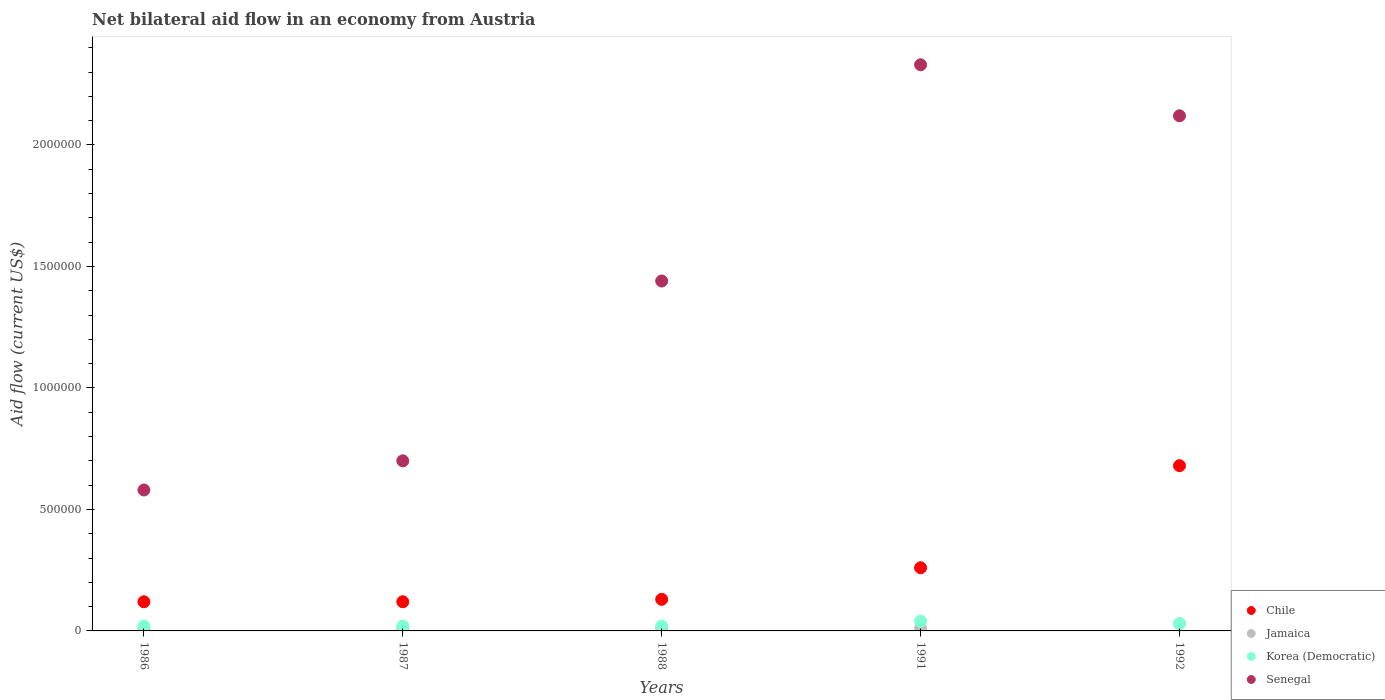Across all years, what is the maximum net bilateral aid flow in Senegal?
Provide a succinct answer. 2.33e+06. Across all years, what is the minimum net bilateral aid flow in Senegal?
Your response must be concise. 5.80e+05. In which year was the net bilateral aid flow in Senegal minimum?
Give a very brief answer. 1986. What is the difference between the net bilateral aid flow in Senegal in 1987 and that in 1988?
Your answer should be compact. -7.40e+05. What is the difference between the net bilateral aid flow in Korea (Democratic) in 1991 and the net bilateral aid flow in Jamaica in 1987?
Your response must be concise. 3.00e+04. What is the average net bilateral aid flow in Senegal per year?
Ensure brevity in your answer.  1.43e+06. In the year 1992, what is the difference between the net bilateral aid flow in Jamaica and net bilateral aid flow in Senegal?
Give a very brief answer. -2.09e+06. What is the ratio of the net bilateral aid flow in Korea (Democratic) in 1986 to that in 1991?
Give a very brief answer. 0.5. Is the difference between the net bilateral aid flow in Jamaica in 1986 and 1988 greater than the difference between the net bilateral aid flow in Senegal in 1986 and 1988?
Keep it short and to the point. Yes. What is the difference between the highest and the second highest net bilateral aid flow in Korea (Democratic)?
Provide a short and direct response. 10000. What is the difference between the highest and the lowest net bilateral aid flow in Chile?
Give a very brief answer. 5.60e+05. Is it the case that in every year, the sum of the net bilateral aid flow in Korea (Democratic) and net bilateral aid flow in Jamaica  is greater than the sum of net bilateral aid flow in Chile and net bilateral aid flow in Senegal?
Make the answer very short. No. Is it the case that in every year, the sum of the net bilateral aid flow in Korea (Democratic) and net bilateral aid flow in Jamaica  is greater than the net bilateral aid flow in Senegal?
Keep it short and to the point. No. Does the net bilateral aid flow in Korea (Democratic) monotonically increase over the years?
Your answer should be very brief. No. Is the net bilateral aid flow in Jamaica strictly greater than the net bilateral aid flow in Senegal over the years?
Provide a succinct answer. No. How many years are there in the graph?
Your response must be concise. 5. Are the values on the major ticks of Y-axis written in scientific E-notation?
Offer a very short reply. No. How many legend labels are there?
Offer a terse response. 4. What is the title of the graph?
Your response must be concise. Net bilateral aid flow in an economy from Austria. Does "New Zealand" appear as one of the legend labels in the graph?
Keep it short and to the point. No. What is the Aid flow (current US$) in Jamaica in 1986?
Your response must be concise. 10000. What is the Aid flow (current US$) of Korea (Democratic) in 1986?
Make the answer very short. 2.00e+04. What is the Aid flow (current US$) of Senegal in 1986?
Provide a short and direct response. 5.80e+05. What is the Aid flow (current US$) of Jamaica in 1987?
Keep it short and to the point. 10000. What is the Aid flow (current US$) in Senegal in 1987?
Your answer should be very brief. 7.00e+05. What is the Aid flow (current US$) of Korea (Democratic) in 1988?
Provide a succinct answer. 2.00e+04. What is the Aid flow (current US$) in Senegal in 1988?
Your answer should be compact. 1.44e+06. What is the Aid flow (current US$) of Chile in 1991?
Provide a short and direct response. 2.60e+05. What is the Aid flow (current US$) in Jamaica in 1991?
Keep it short and to the point. 10000. What is the Aid flow (current US$) of Korea (Democratic) in 1991?
Provide a short and direct response. 4.00e+04. What is the Aid flow (current US$) of Senegal in 1991?
Make the answer very short. 2.33e+06. What is the Aid flow (current US$) of Chile in 1992?
Offer a very short reply. 6.80e+05. What is the Aid flow (current US$) in Jamaica in 1992?
Your answer should be compact. 3.00e+04. What is the Aid flow (current US$) in Senegal in 1992?
Offer a terse response. 2.12e+06. Across all years, what is the maximum Aid flow (current US$) in Chile?
Provide a succinct answer. 6.80e+05. Across all years, what is the maximum Aid flow (current US$) of Jamaica?
Your answer should be compact. 3.00e+04. Across all years, what is the maximum Aid flow (current US$) in Korea (Democratic)?
Your answer should be very brief. 4.00e+04. Across all years, what is the maximum Aid flow (current US$) in Senegal?
Offer a very short reply. 2.33e+06. Across all years, what is the minimum Aid flow (current US$) of Jamaica?
Offer a terse response. 10000. Across all years, what is the minimum Aid flow (current US$) of Senegal?
Your answer should be compact. 5.80e+05. What is the total Aid flow (current US$) of Chile in the graph?
Your response must be concise. 1.31e+06. What is the total Aid flow (current US$) in Jamaica in the graph?
Keep it short and to the point. 7.00e+04. What is the total Aid flow (current US$) in Senegal in the graph?
Your answer should be compact. 7.17e+06. What is the difference between the Aid flow (current US$) in Chile in 1986 and that in 1987?
Keep it short and to the point. 0. What is the difference between the Aid flow (current US$) in Jamaica in 1986 and that in 1987?
Offer a terse response. 0. What is the difference between the Aid flow (current US$) of Korea (Democratic) in 1986 and that in 1987?
Your response must be concise. 0. What is the difference between the Aid flow (current US$) in Senegal in 1986 and that in 1987?
Your answer should be very brief. -1.20e+05. What is the difference between the Aid flow (current US$) of Jamaica in 1986 and that in 1988?
Your answer should be compact. 0. What is the difference between the Aid flow (current US$) of Korea (Democratic) in 1986 and that in 1988?
Keep it short and to the point. 0. What is the difference between the Aid flow (current US$) of Senegal in 1986 and that in 1988?
Give a very brief answer. -8.60e+05. What is the difference between the Aid flow (current US$) of Chile in 1986 and that in 1991?
Offer a terse response. -1.40e+05. What is the difference between the Aid flow (current US$) in Jamaica in 1986 and that in 1991?
Offer a very short reply. 0. What is the difference between the Aid flow (current US$) in Korea (Democratic) in 1986 and that in 1991?
Your answer should be very brief. -2.00e+04. What is the difference between the Aid flow (current US$) in Senegal in 1986 and that in 1991?
Ensure brevity in your answer.  -1.75e+06. What is the difference between the Aid flow (current US$) of Chile in 1986 and that in 1992?
Your response must be concise. -5.60e+05. What is the difference between the Aid flow (current US$) in Senegal in 1986 and that in 1992?
Keep it short and to the point. -1.54e+06. What is the difference between the Aid flow (current US$) of Chile in 1987 and that in 1988?
Offer a very short reply. -10000. What is the difference between the Aid flow (current US$) of Jamaica in 1987 and that in 1988?
Offer a very short reply. 0. What is the difference between the Aid flow (current US$) in Korea (Democratic) in 1987 and that in 1988?
Make the answer very short. 0. What is the difference between the Aid flow (current US$) of Senegal in 1987 and that in 1988?
Provide a short and direct response. -7.40e+05. What is the difference between the Aid flow (current US$) in Chile in 1987 and that in 1991?
Provide a short and direct response. -1.40e+05. What is the difference between the Aid flow (current US$) of Korea (Democratic) in 1987 and that in 1991?
Make the answer very short. -2.00e+04. What is the difference between the Aid flow (current US$) in Senegal in 1987 and that in 1991?
Provide a succinct answer. -1.63e+06. What is the difference between the Aid flow (current US$) of Chile in 1987 and that in 1992?
Give a very brief answer. -5.60e+05. What is the difference between the Aid flow (current US$) in Senegal in 1987 and that in 1992?
Make the answer very short. -1.42e+06. What is the difference between the Aid flow (current US$) in Chile in 1988 and that in 1991?
Make the answer very short. -1.30e+05. What is the difference between the Aid flow (current US$) in Jamaica in 1988 and that in 1991?
Your answer should be compact. 0. What is the difference between the Aid flow (current US$) in Senegal in 1988 and that in 1991?
Ensure brevity in your answer.  -8.90e+05. What is the difference between the Aid flow (current US$) of Chile in 1988 and that in 1992?
Offer a very short reply. -5.50e+05. What is the difference between the Aid flow (current US$) of Jamaica in 1988 and that in 1992?
Give a very brief answer. -2.00e+04. What is the difference between the Aid flow (current US$) in Korea (Democratic) in 1988 and that in 1992?
Your response must be concise. -10000. What is the difference between the Aid flow (current US$) in Senegal in 1988 and that in 1992?
Offer a terse response. -6.80e+05. What is the difference between the Aid flow (current US$) of Chile in 1991 and that in 1992?
Your answer should be compact. -4.20e+05. What is the difference between the Aid flow (current US$) in Korea (Democratic) in 1991 and that in 1992?
Give a very brief answer. 10000. What is the difference between the Aid flow (current US$) of Chile in 1986 and the Aid flow (current US$) of Jamaica in 1987?
Your answer should be compact. 1.10e+05. What is the difference between the Aid flow (current US$) of Chile in 1986 and the Aid flow (current US$) of Korea (Democratic) in 1987?
Make the answer very short. 1.00e+05. What is the difference between the Aid flow (current US$) in Chile in 1986 and the Aid flow (current US$) in Senegal in 1987?
Ensure brevity in your answer.  -5.80e+05. What is the difference between the Aid flow (current US$) of Jamaica in 1986 and the Aid flow (current US$) of Senegal in 1987?
Provide a short and direct response. -6.90e+05. What is the difference between the Aid flow (current US$) of Korea (Democratic) in 1986 and the Aid flow (current US$) of Senegal in 1987?
Keep it short and to the point. -6.80e+05. What is the difference between the Aid flow (current US$) of Chile in 1986 and the Aid flow (current US$) of Jamaica in 1988?
Make the answer very short. 1.10e+05. What is the difference between the Aid flow (current US$) of Chile in 1986 and the Aid flow (current US$) of Senegal in 1988?
Your answer should be compact. -1.32e+06. What is the difference between the Aid flow (current US$) of Jamaica in 1986 and the Aid flow (current US$) of Korea (Democratic) in 1988?
Your response must be concise. -10000. What is the difference between the Aid flow (current US$) of Jamaica in 1986 and the Aid flow (current US$) of Senegal in 1988?
Offer a terse response. -1.43e+06. What is the difference between the Aid flow (current US$) in Korea (Democratic) in 1986 and the Aid flow (current US$) in Senegal in 1988?
Give a very brief answer. -1.42e+06. What is the difference between the Aid flow (current US$) of Chile in 1986 and the Aid flow (current US$) of Senegal in 1991?
Provide a succinct answer. -2.21e+06. What is the difference between the Aid flow (current US$) in Jamaica in 1986 and the Aid flow (current US$) in Korea (Democratic) in 1991?
Provide a succinct answer. -3.00e+04. What is the difference between the Aid flow (current US$) of Jamaica in 1986 and the Aid flow (current US$) of Senegal in 1991?
Your answer should be compact. -2.32e+06. What is the difference between the Aid flow (current US$) in Korea (Democratic) in 1986 and the Aid flow (current US$) in Senegal in 1991?
Provide a short and direct response. -2.31e+06. What is the difference between the Aid flow (current US$) of Chile in 1986 and the Aid flow (current US$) of Jamaica in 1992?
Keep it short and to the point. 9.00e+04. What is the difference between the Aid flow (current US$) of Jamaica in 1986 and the Aid flow (current US$) of Senegal in 1992?
Give a very brief answer. -2.11e+06. What is the difference between the Aid flow (current US$) of Korea (Democratic) in 1986 and the Aid flow (current US$) of Senegal in 1992?
Offer a terse response. -2.10e+06. What is the difference between the Aid flow (current US$) of Chile in 1987 and the Aid flow (current US$) of Korea (Democratic) in 1988?
Keep it short and to the point. 1.00e+05. What is the difference between the Aid flow (current US$) of Chile in 1987 and the Aid flow (current US$) of Senegal in 1988?
Give a very brief answer. -1.32e+06. What is the difference between the Aid flow (current US$) of Jamaica in 1987 and the Aid flow (current US$) of Korea (Democratic) in 1988?
Make the answer very short. -10000. What is the difference between the Aid flow (current US$) of Jamaica in 1987 and the Aid flow (current US$) of Senegal in 1988?
Your response must be concise. -1.43e+06. What is the difference between the Aid flow (current US$) in Korea (Democratic) in 1987 and the Aid flow (current US$) in Senegal in 1988?
Provide a short and direct response. -1.42e+06. What is the difference between the Aid flow (current US$) in Chile in 1987 and the Aid flow (current US$) in Senegal in 1991?
Offer a terse response. -2.21e+06. What is the difference between the Aid flow (current US$) in Jamaica in 1987 and the Aid flow (current US$) in Korea (Democratic) in 1991?
Offer a terse response. -3.00e+04. What is the difference between the Aid flow (current US$) in Jamaica in 1987 and the Aid flow (current US$) in Senegal in 1991?
Ensure brevity in your answer.  -2.32e+06. What is the difference between the Aid flow (current US$) of Korea (Democratic) in 1987 and the Aid flow (current US$) of Senegal in 1991?
Your answer should be very brief. -2.31e+06. What is the difference between the Aid flow (current US$) in Chile in 1987 and the Aid flow (current US$) in Jamaica in 1992?
Provide a short and direct response. 9.00e+04. What is the difference between the Aid flow (current US$) in Chile in 1987 and the Aid flow (current US$) in Senegal in 1992?
Your answer should be very brief. -2.00e+06. What is the difference between the Aid flow (current US$) of Jamaica in 1987 and the Aid flow (current US$) of Senegal in 1992?
Give a very brief answer. -2.11e+06. What is the difference between the Aid flow (current US$) in Korea (Democratic) in 1987 and the Aid flow (current US$) in Senegal in 1992?
Keep it short and to the point. -2.10e+06. What is the difference between the Aid flow (current US$) of Chile in 1988 and the Aid flow (current US$) of Korea (Democratic) in 1991?
Provide a short and direct response. 9.00e+04. What is the difference between the Aid flow (current US$) in Chile in 1988 and the Aid flow (current US$) in Senegal in 1991?
Give a very brief answer. -2.20e+06. What is the difference between the Aid flow (current US$) of Jamaica in 1988 and the Aid flow (current US$) of Korea (Democratic) in 1991?
Your answer should be very brief. -3.00e+04. What is the difference between the Aid flow (current US$) in Jamaica in 1988 and the Aid flow (current US$) in Senegal in 1991?
Make the answer very short. -2.32e+06. What is the difference between the Aid flow (current US$) of Korea (Democratic) in 1988 and the Aid flow (current US$) of Senegal in 1991?
Keep it short and to the point. -2.31e+06. What is the difference between the Aid flow (current US$) of Chile in 1988 and the Aid flow (current US$) of Korea (Democratic) in 1992?
Offer a very short reply. 1.00e+05. What is the difference between the Aid flow (current US$) in Chile in 1988 and the Aid flow (current US$) in Senegal in 1992?
Give a very brief answer. -1.99e+06. What is the difference between the Aid flow (current US$) in Jamaica in 1988 and the Aid flow (current US$) in Senegal in 1992?
Provide a succinct answer. -2.11e+06. What is the difference between the Aid flow (current US$) of Korea (Democratic) in 1988 and the Aid flow (current US$) of Senegal in 1992?
Offer a terse response. -2.10e+06. What is the difference between the Aid flow (current US$) of Chile in 1991 and the Aid flow (current US$) of Senegal in 1992?
Offer a terse response. -1.86e+06. What is the difference between the Aid flow (current US$) in Jamaica in 1991 and the Aid flow (current US$) in Korea (Democratic) in 1992?
Offer a very short reply. -2.00e+04. What is the difference between the Aid flow (current US$) of Jamaica in 1991 and the Aid flow (current US$) of Senegal in 1992?
Keep it short and to the point. -2.11e+06. What is the difference between the Aid flow (current US$) of Korea (Democratic) in 1991 and the Aid flow (current US$) of Senegal in 1992?
Give a very brief answer. -2.08e+06. What is the average Aid flow (current US$) in Chile per year?
Offer a very short reply. 2.62e+05. What is the average Aid flow (current US$) of Jamaica per year?
Provide a short and direct response. 1.40e+04. What is the average Aid flow (current US$) of Korea (Democratic) per year?
Provide a short and direct response. 2.60e+04. What is the average Aid flow (current US$) in Senegal per year?
Offer a very short reply. 1.43e+06. In the year 1986, what is the difference between the Aid flow (current US$) of Chile and Aid flow (current US$) of Korea (Democratic)?
Give a very brief answer. 1.00e+05. In the year 1986, what is the difference between the Aid flow (current US$) of Chile and Aid flow (current US$) of Senegal?
Ensure brevity in your answer.  -4.60e+05. In the year 1986, what is the difference between the Aid flow (current US$) in Jamaica and Aid flow (current US$) in Korea (Democratic)?
Provide a short and direct response. -10000. In the year 1986, what is the difference between the Aid flow (current US$) in Jamaica and Aid flow (current US$) in Senegal?
Offer a very short reply. -5.70e+05. In the year 1986, what is the difference between the Aid flow (current US$) in Korea (Democratic) and Aid flow (current US$) in Senegal?
Make the answer very short. -5.60e+05. In the year 1987, what is the difference between the Aid flow (current US$) in Chile and Aid flow (current US$) in Senegal?
Ensure brevity in your answer.  -5.80e+05. In the year 1987, what is the difference between the Aid flow (current US$) in Jamaica and Aid flow (current US$) in Korea (Democratic)?
Make the answer very short. -10000. In the year 1987, what is the difference between the Aid flow (current US$) of Jamaica and Aid flow (current US$) of Senegal?
Give a very brief answer. -6.90e+05. In the year 1987, what is the difference between the Aid flow (current US$) of Korea (Democratic) and Aid flow (current US$) of Senegal?
Keep it short and to the point. -6.80e+05. In the year 1988, what is the difference between the Aid flow (current US$) in Chile and Aid flow (current US$) in Jamaica?
Offer a terse response. 1.20e+05. In the year 1988, what is the difference between the Aid flow (current US$) in Chile and Aid flow (current US$) in Senegal?
Give a very brief answer. -1.31e+06. In the year 1988, what is the difference between the Aid flow (current US$) of Jamaica and Aid flow (current US$) of Senegal?
Your answer should be compact. -1.43e+06. In the year 1988, what is the difference between the Aid flow (current US$) in Korea (Democratic) and Aid flow (current US$) in Senegal?
Give a very brief answer. -1.42e+06. In the year 1991, what is the difference between the Aid flow (current US$) in Chile and Aid flow (current US$) in Jamaica?
Your answer should be very brief. 2.50e+05. In the year 1991, what is the difference between the Aid flow (current US$) in Chile and Aid flow (current US$) in Senegal?
Keep it short and to the point. -2.07e+06. In the year 1991, what is the difference between the Aid flow (current US$) in Jamaica and Aid flow (current US$) in Senegal?
Give a very brief answer. -2.32e+06. In the year 1991, what is the difference between the Aid flow (current US$) of Korea (Democratic) and Aid flow (current US$) of Senegal?
Offer a terse response. -2.29e+06. In the year 1992, what is the difference between the Aid flow (current US$) of Chile and Aid flow (current US$) of Jamaica?
Provide a short and direct response. 6.50e+05. In the year 1992, what is the difference between the Aid flow (current US$) of Chile and Aid flow (current US$) of Korea (Democratic)?
Ensure brevity in your answer.  6.50e+05. In the year 1992, what is the difference between the Aid flow (current US$) in Chile and Aid flow (current US$) in Senegal?
Your answer should be very brief. -1.44e+06. In the year 1992, what is the difference between the Aid flow (current US$) of Jamaica and Aid flow (current US$) of Korea (Democratic)?
Provide a succinct answer. 0. In the year 1992, what is the difference between the Aid flow (current US$) of Jamaica and Aid flow (current US$) of Senegal?
Keep it short and to the point. -2.09e+06. In the year 1992, what is the difference between the Aid flow (current US$) in Korea (Democratic) and Aid flow (current US$) in Senegal?
Provide a short and direct response. -2.09e+06. What is the ratio of the Aid flow (current US$) of Senegal in 1986 to that in 1987?
Provide a short and direct response. 0.83. What is the ratio of the Aid flow (current US$) in Korea (Democratic) in 1986 to that in 1988?
Your answer should be very brief. 1. What is the ratio of the Aid flow (current US$) in Senegal in 1986 to that in 1988?
Offer a very short reply. 0.4. What is the ratio of the Aid flow (current US$) in Chile in 1986 to that in 1991?
Ensure brevity in your answer.  0.46. What is the ratio of the Aid flow (current US$) in Senegal in 1986 to that in 1991?
Provide a succinct answer. 0.25. What is the ratio of the Aid flow (current US$) in Chile in 1986 to that in 1992?
Offer a very short reply. 0.18. What is the ratio of the Aid flow (current US$) of Jamaica in 1986 to that in 1992?
Your answer should be compact. 0.33. What is the ratio of the Aid flow (current US$) of Senegal in 1986 to that in 1992?
Provide a short and direct response. 0.27. What is the ratio of the Aid flow (current US$) of Jamaica in 1987 to that in 1988?
Give a very brief answer. 1. What is the ratio of the Aid flow (current US$) of Senegal in 1987 to that in 1988?
Provide a succinct answer. 0.49. What is the ratio of the Aid flow (current US$) of Chile in 1987 to that in 1991?
Provide a succinct answer. 0.46. What is the ratio of the Aid flow (current US$) of Jamaica in 1987 to that in 1991?
Make the answer very short. 1. What is the ratio of the Aid flow (current US$) of Senegal in 1987 to that in 1991?
Keep it short and to the point. 0.3. What is the ratio of the Aid flow (current US$) of Chile in 1987 to that in 1992?
Your answer should be very brief. 0.18. What is the ratio of the Aid flow (current US$) of Jamaica in 1987 to that in 1992?
Offer a terse response. 0.33. What is the ratio of the Aid flow (current US$) of Korea (Democratic) in 1987 to that in 1992?
Your response must be concise. 0.67. What is the ratio of the Aid flow (current US$) of Senegal in 1987 to that in 1992?
Give a very brief answer. 0.33. What is the ratio of the Aid flow (current US$) in Jamaica in 1988 to that in 1991?
Make the answer very short. 1. What is the ratio of the Aid flow (current US$) of Korea (Democratic) in 1988 to that in 1991?
Provide a short and direct response. 0.5. What is the ratio of the Aid flow (current US$) of Senegal in 1988 to that in 1991?
Your answer should be compact. 0.62. What is the ratio of the Aid flow (current US$) in Chile in 1988 to that in 1992?
Ensure brevity in your answer.  0.19. What is the ratio of the Aid flow (current US$) in Jamaica in 1988 to that in 1992?
Provide a short and direct response. 0.33. What is the ratio of the Aid flow (current US$) in Korea (Democratic) in 1988 to that in 1992?
Provide a short and direct response. 0.67. What is the ratio of the Aid flow (current US$) of Senegal in 1988 to that in 1992?
Your answer should be very brief. 0.68. What is the ratio of the Aid flow (current US$) of Chile in 1991 to that in 1992?
Offer a terse response. 0.38. What is the ratio of the Aid flow (current US$) in Jamaica in 1991 to that in 1992?
Provide a succinct answer. 0.33. What is the ratio of the Aid flow (current US$) of Korea (Democratic) in 1991 to that in 1992?
Offer a terse response. 1.33. What is the ratio of the Aid flow (current US$) of Senegal in 1991 to that in 1992?
Keep it short and to the point. 1.1. What is the difference between the highest and the second highest Aid flow (current US$) in Chile?
Provide a short and direct response. 4.20e+05. What is the difference between the highest and the lowest Aid flow (current US$) in Chile?
Your answer should be very brief. 5.60e+05. What is the difference between the highest and the lowest Aid flow (current US$) of Jamaica?
Your response must be concise. 2.00e+04. What is the difference between the highest and the lowest Aid flow (current US$) in Senegal?
Provide a short and direct response. 1.75e+06. 